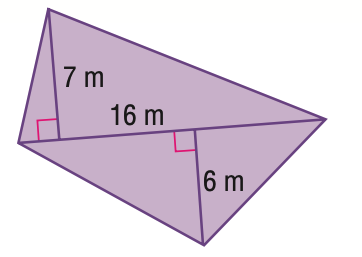Answer the mathemtical geometry problem and directly provide the correct option letter.
Question: Find the area of the quadrilateral.
Choices: A: 96 B: 104 C: 112 D: 208 B 